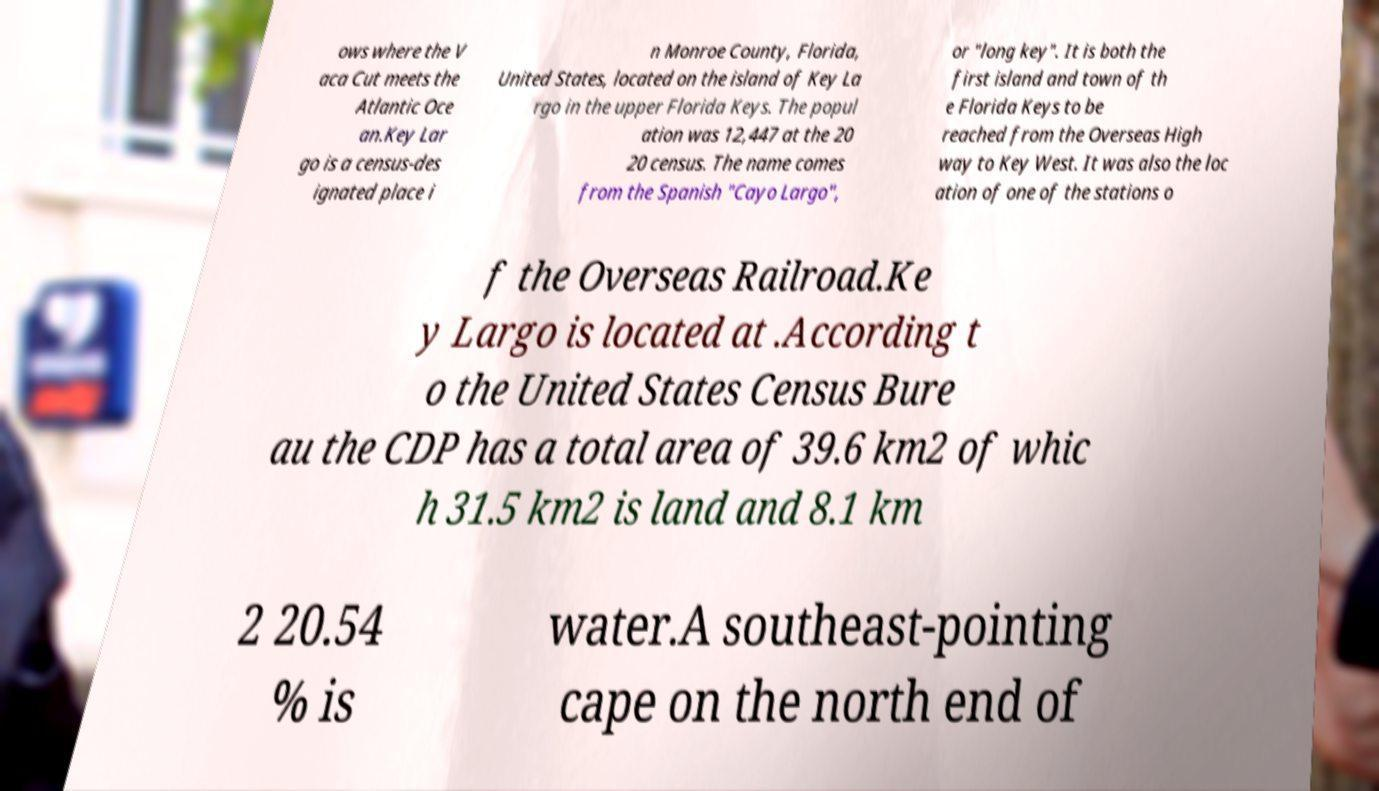Could you extract and type out the text from this image? ows where the V aca Cut meets the Atlantic Oce an.Key Lar go is a census-des ignated place i n Monroe County, Florida, United States, located on the island of Key La rgo in the upper Florida Keys. The popul ation was 12,447 at the 20 20 census. The name comes from the Spanish "Cayo Largo", or "long key". It is both the first island and town of th e Florida Keys to be reached from the Overseas High way to Key West. It was also the loc ation of one of the stations o f the Overseas Railroad.Ke y Largo is located at .According t o the United States Census Bure au the CDP has a total area of 39.6 km2 of whic h 31.5 km2 is land and 8.1 km 2 20.54 % is water.A southeast-pointing cape on the north end of 